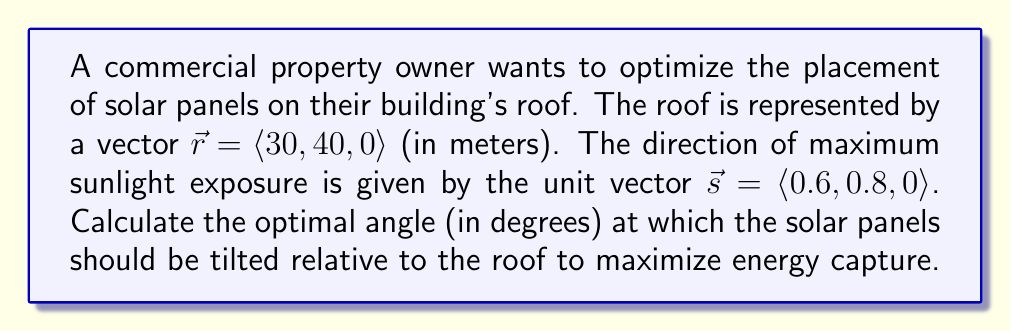Can you answer this question? To solve this problem, we'll use vector operations and the dot product. Here's the step-by-step solution:

1) The optimal angle for solar panels is when they are perpendicular to the direction of sunlight. We can find this angle by calculating the angle between the roof vector and the sunlight vector.

2) The angle between two vectors can be found using the dot product formula:

   $$\cos \theta = \frac{\vec{r} \cdot \vec{s}}{|\vec{r}||\vec{s}|}$$

3) First, let's calculate the dot product $\vec{r} \cdot \vec{s}$:
   
   $$\vec{r} \cdot \vec{s} = (30 \times 0.6) + (40 \times 0.8) + (0 \times 0) = 18 + 32 = 50$$

4) Now, let's calculate the magnitudes of $\vec{r}$ and $\vec{s}$:
   
   $$|\vec{r}| = \sqrt{30^2 + 40^2 + 0^2} = \sqrt{900 + 1600} = \sqrt{2500} = 50$$
   
   $$|\vec{s}| = 1$$ (since it's a unit vector)

5) Substituting these values into the dot product formula:

   $$\cos \theta = \frac{50}{50 \times 1} = 1$$

6) Taking the inverse cosine (arccos) of both sides:

   $$\theta = \arccos(1) = 0^\circ$$

7) This angle represents the angle between the roof and the sunlight direction. To find the tilt angle for the solar panels, we need to subtract this from 90°:

   $$\text{Tilt angle} = 90^\circ - 0^\circ = 90^\circ$$
Answer: The optimal tilt angle for the solar panels is 90°. 